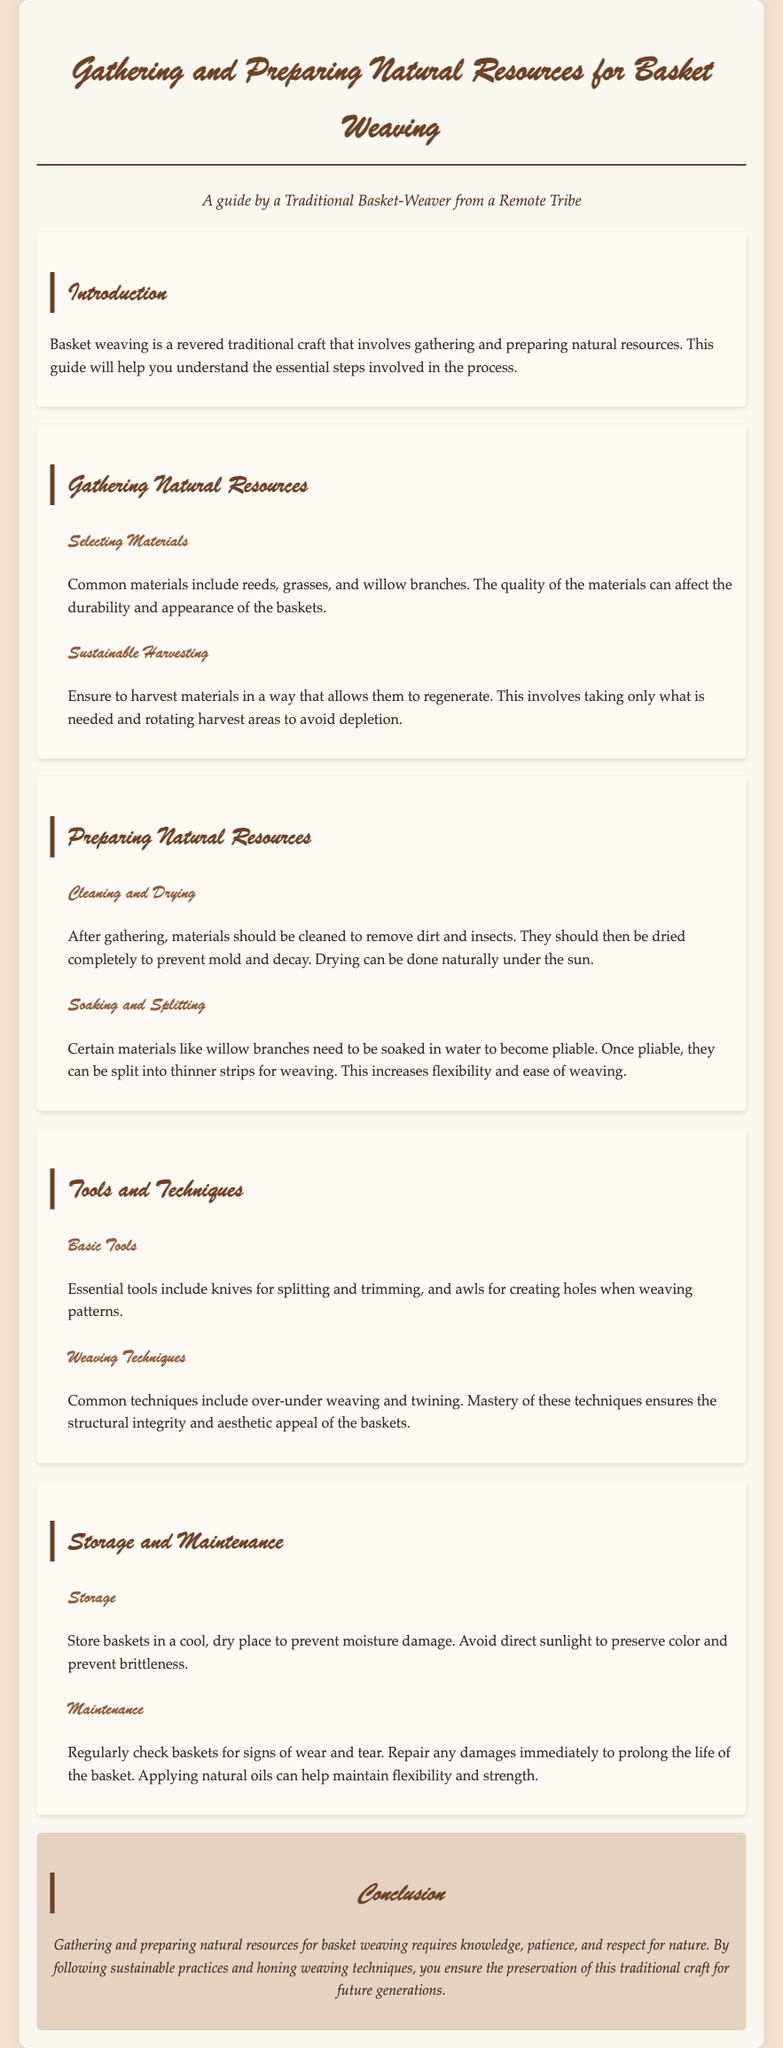What are common materials used for basket weaving? The document lists reeds, grasses, and willow branches as common materials for basket weaving.
Answer: Reeds, grasses, and willow branches What should be ensured during sustainable harvesting? The guide emphasizes that harvesting should allow materials to regenerate by taking only what is needed and rotating harvest areas.
Answer: Regeneration What is the first step after gathering materials? According to the document, the first step after gathering materials is cleaning them to remove dirt and insects.
Answer: Cleaning How can willow branches be made pliable? The document states that willow branches need to be soaked in water to become pliable.
Answer: Soaked in water What basic tools are essential for basket weaving? The document mentions knives for splitting and trimming, and awls for creating holes as essential tools.
Answer: Knives and awls What is the purpose of applying natural oils to baskets? The guide explains that applying natural oils can help maintain flexibility and strength of the baskets.
Answer: Maintain flexibility and strength Where should baskets be stored to prevent damage? The document advises storing baskets in a cool, dry place to prevent moisture damage.
Answer: Cool, dry place Which weaving technique helps ensure structural integrity? The guide mentions that mastery of over-under weaving technique ensures structural integrity of the baskets.
Answer: Over-under weaving How does sustainable harvesting benefit basket weaving? The document indicates that sustainable harvesting practices allow for continued access to natural resources vital for basket weaving.
Answer: Continued access to resources 